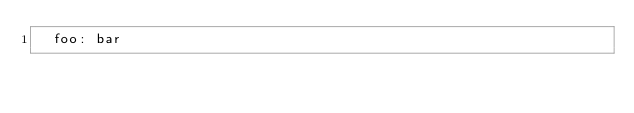<code> <loc_0><loc_0><loc_500><loc_500><_YAML_>  foo: bar
</code> 